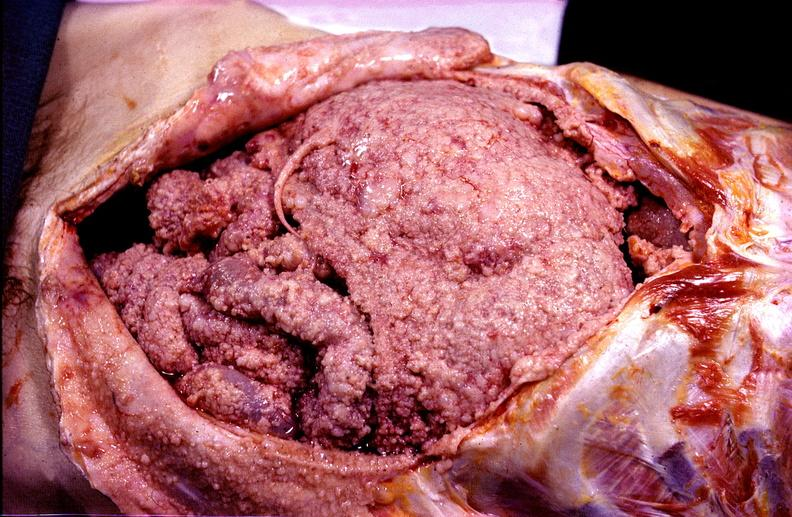what does this image show?
Answer the question using a single word or phrase. Peritoneal carcinomatosis 